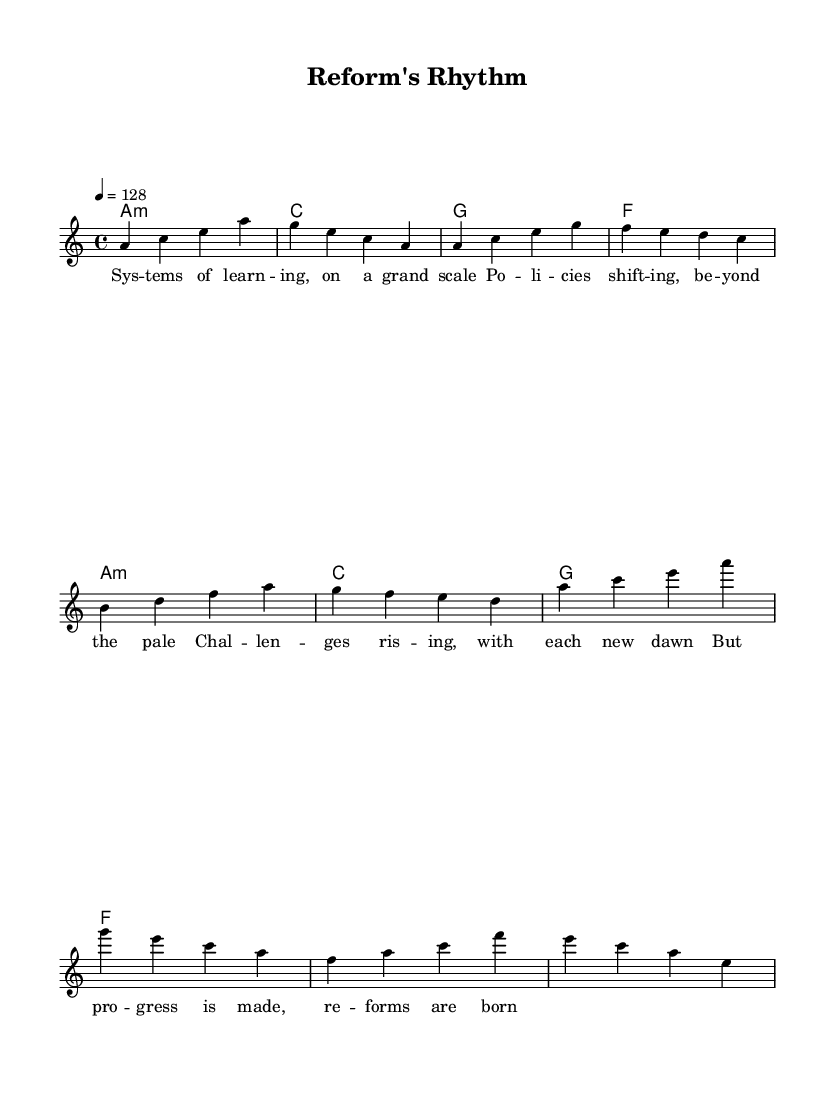What is the key signature of this music? The key signature is A minor, which is indicated by no sharps or flats on the staff.
Answer: A minor What is the time signature of this music? The time signature is 4/4, which means there are four beats in each measure and the quarter note receives one beat, as indicated at the beginning of the staff.
Answer: 4/4 What is the tempo marking for this piece? The tempo marking is 128 beats per minute, specified at the beginning of the piece with the tempo indication.
Answer: 128 How many measures are in the verse section? The verse section contains four measures, as counted from the melody line where the verse lyrics align with the music.
Answer: 4 What is the final chord of the chorus section? The final chord of the chorus is E major, identified by the harmony line which shows the progression of chords leading to an E major chord.
Answer: E major What lyrical theme is addressed in the song? The lyrical theme is educational reform, focusing on challenges and progress within large-scale learning systems, as interpreted from the sheet music lyrics.
Answer: Educational reform What type of music is this composition? This composition is categorized as melodic house, a genre known for its danceable rhythm and emotional melodies, as indicated by its stylistic elements in the music structure.
Answer: Melodic house 